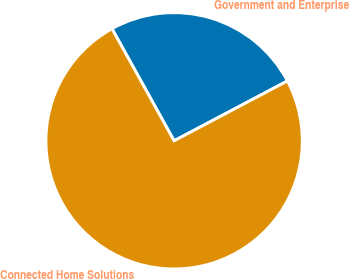Convert chart to OTSL. <chart><loc_0><loc_0><loc_500><loc_500><pie_chart><fcel>Government and Enterprise<fcel>Connected Home Solutions<nl><fcel>25.32%<fcel>74.68%<nl></chart> 